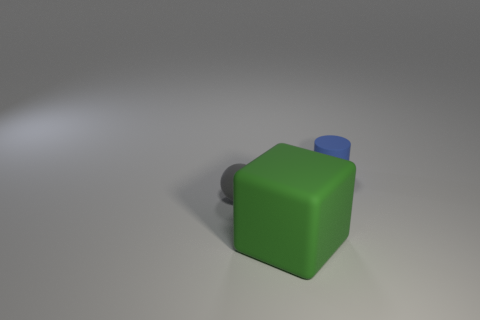Add 2 tiny balls. How many objects exist? 5 Subtract all cylinders. How many objects are left? 2 Subtract all big blue metal balls. Subtract all green objects. How many objects are left? 2 Add 1 matte balls. How many matte balls are left? 2 Add 1 brown metal objects. How many brown metal objects exist? 1 Subtract 0 red cubes. How many objects are left? 3 